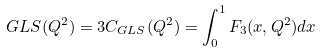Convert formula to latex. <formula><loc_0><loc_0><loc_500><loc_500>G L S ( Q ^ { 2 } ) = 3 C _ { G L S } ( Q ^ { 2 } ) = \int _ { 0 } ^ { 1 } F _ { 3 } ( x , Q ^ { 2 } ) d x</formula> 